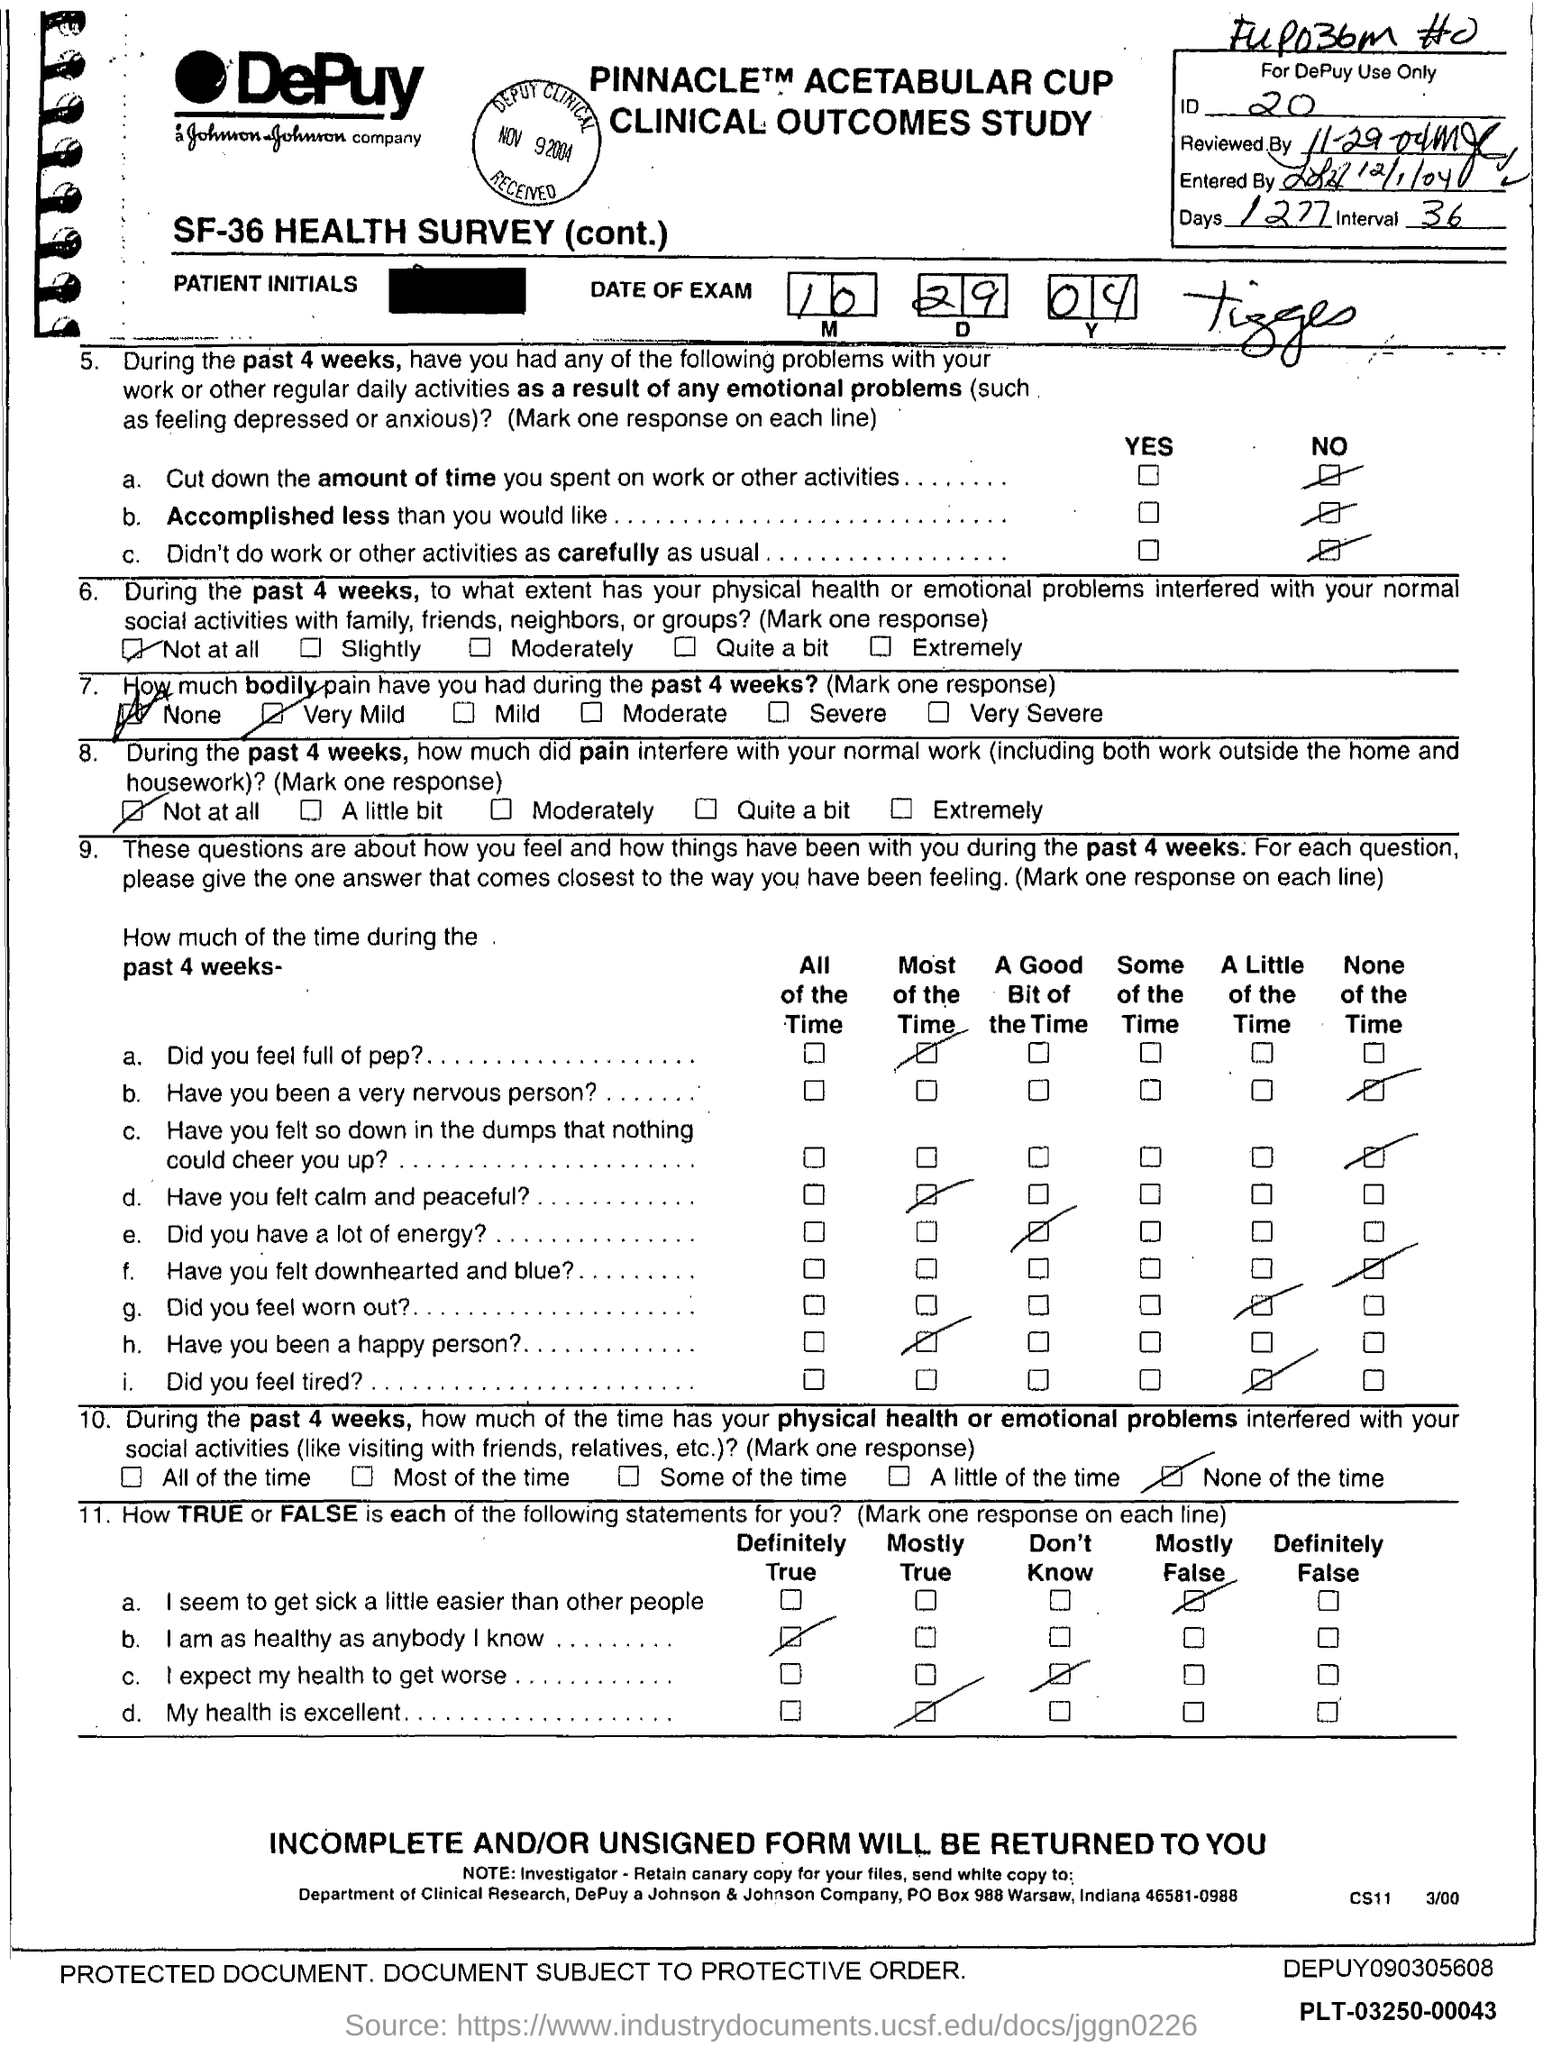List a handful of essential elements in this visual. The number of days mentioned on the top right corner is 1277. I, [person], declare that the DePuy company is located in the city of Warsaw. 